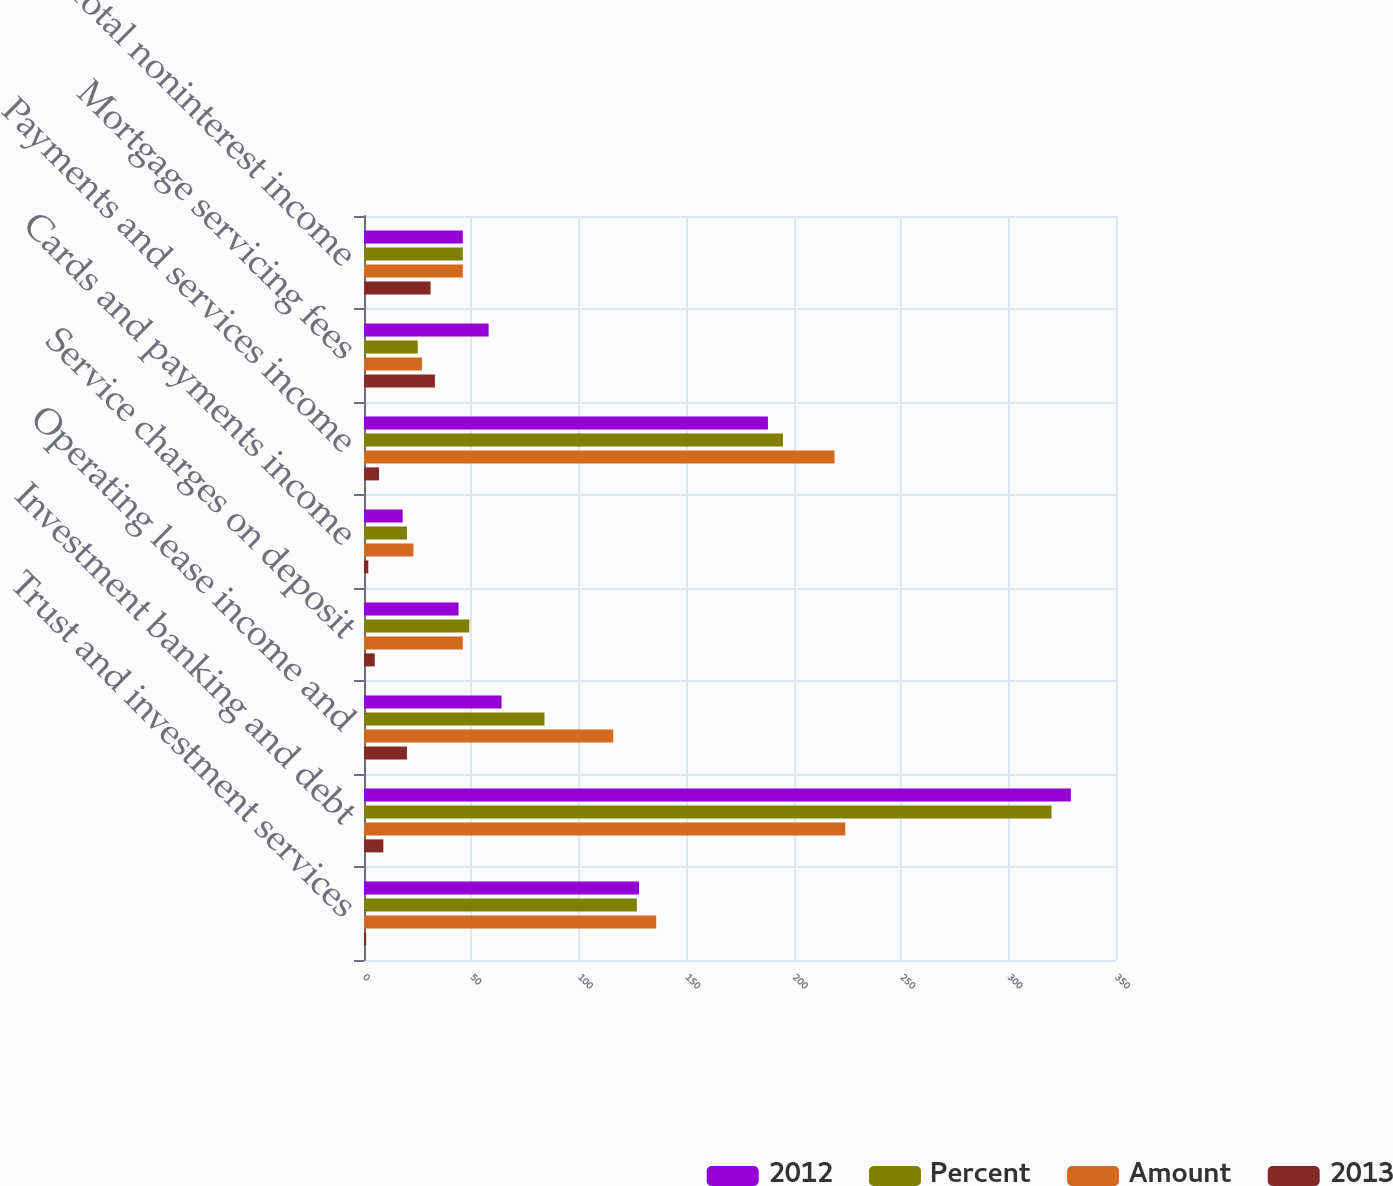Convert chart to OTSL. <chart><loc_0><loc_0><loc_500><loc_500><stacked_bar_chart><ecel><fcel>Trust and investment services<fcel>Investment banking and debt<fcel>Operating lease income and<fcel>Service charges on deposit<fcel>Cards and payments income<fcel>Payments and services income<fcel>Mortgage servicing fees<fcel>Total noninterest income<nl><fcel>2012<fcel>128<fcel>329<fcel>64<fcel>44<fcel>18<fcel>188<fcel>58<fcel>46<nl><fcel>Percent<fcel>127<fcel>320<fcel>84<fcel>49<fcel>20<fcel>195<fcel>25<fcel>46<nl><fcel>Amount<fcel>136<fcel>224<fcel>116<fcel>46<fcel>23<fcel>219<fcel>27<fcel>46<nl><fcel>2013<fcel>1<fcel>9<fcel>20<fcel>5<fcel>2<fcel>7<fcel>33<fcel>31<nl></chart> 